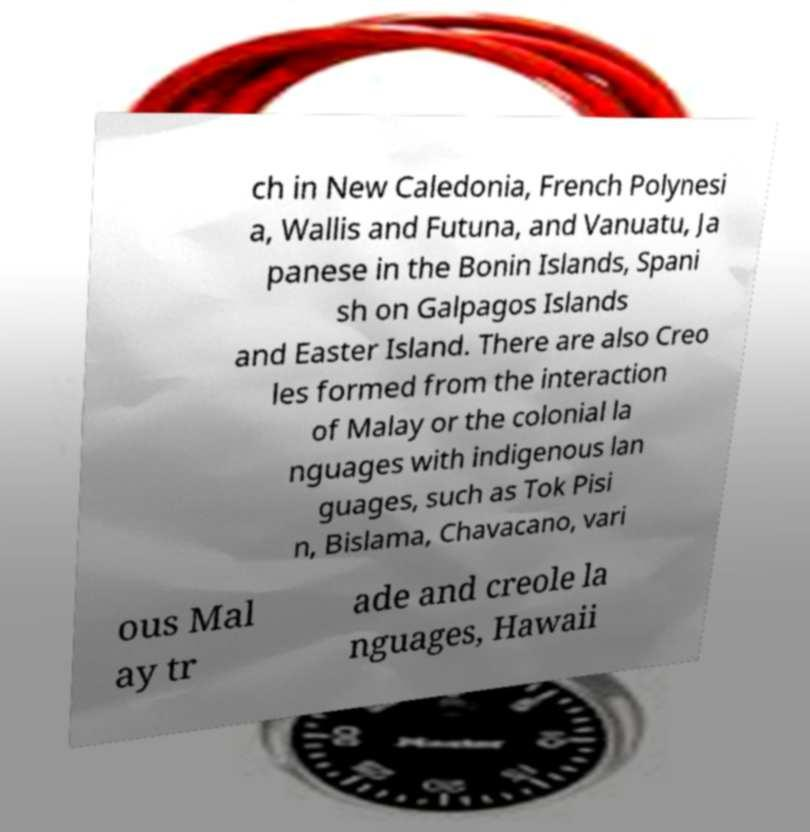Can you accurately transcribe the text from the provided image for me? ch in New Caledonia, French Polynesi a, Wallis and Futuna, and Vanuatu, Ja panese in the Bonin Islands, Spani sh on Galpagos Islands and Easter Island. There are also Creo les formed from the interaction of Malay or the colonial la nguages with indigenous lan guages, such as Tok Pisi n, Bislama, Chavacano, vari ous Mal ay tr ade and creole la nguages, Hawaii 